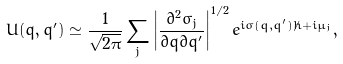<formula> <loc_0><loc_0><loc_500><loc_500>U ( q , q ^ { \prime } ) \simeq \frac { 1 } { \sqrt { 2 \pi } } \sum _ { j } \left | \frac { \partial ^ { 2 } \sigma _ { j } } { \partial q \partial q ^ { \prime } } \right | ^ { 1 / 2 } e ^ { i \sigma ( q , q ^ { \prime } ) / \hbar { + } i \mu _ { j } } ,</formula> 